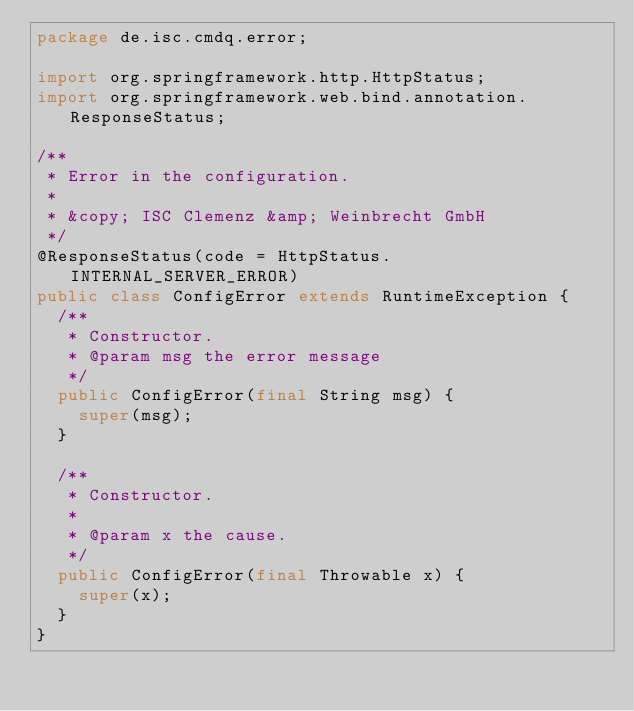<code> <loc_0><loc_0><loc_500><loc_500><_Java_>package de.isc.cmdq.error;

import org.springframework.http.HttpStatus;
import org.springframework.web.bind.annotation.ResponseStatus;

/**
 * Error in the configuration.
 *
 * &copy; ISC Clemenz &amp; Weinbrecht GmbH
 */
@ResponseStatus(code = HttpStatus.INTERNAL_SERVER_ERROR)
public class ConfigError extends RuntimeException {
  /**
   * Constructor.
   * @param msg the error message
   */
  public ConfigError(final String msg) {
    super(msg);
  }

  /**
   * Constructor.
   *
   * @param x the cause.
   */
  public ConfigError(final Throwable x) {
    super(x);
  }
}
</code> 